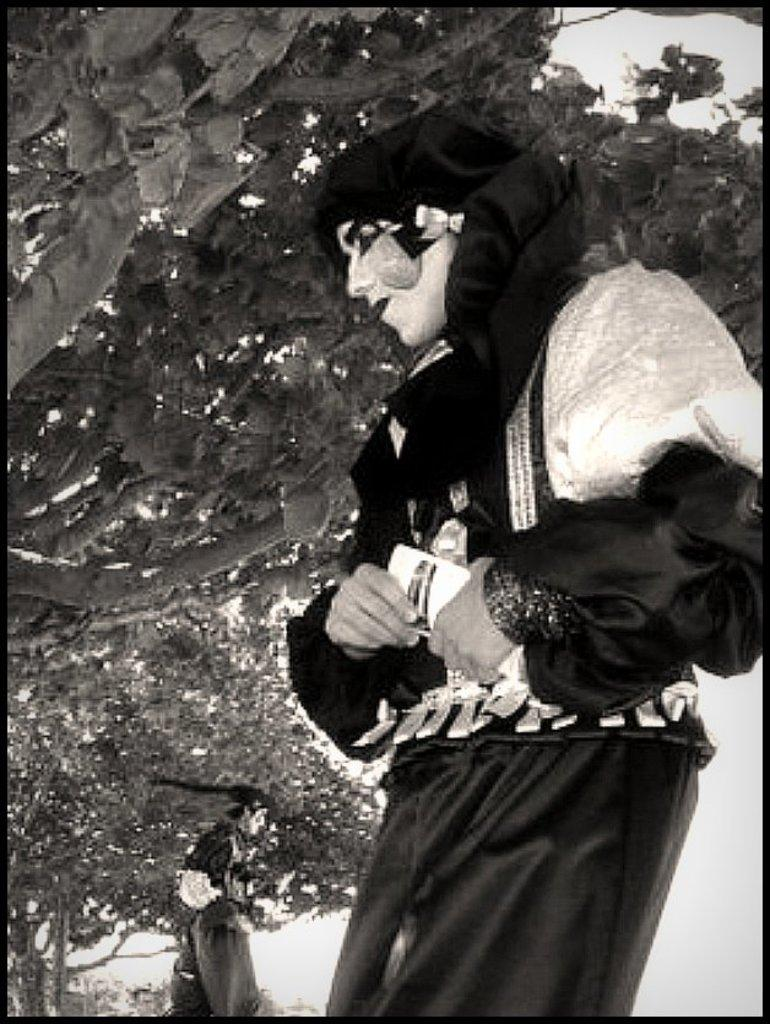What can be seen on the right side of the image? There is a person on the right side of the image. What is the person wearing? The person is wearing a costume. What is the person holding? The person is holding something. What is on the left side of the image? There is another person on the left side of the image and an object. What type of vegetation is present in the image? There are trees in the image. What type of stamp can be seen on the costume of the person on the right side of the image? There is no stamp visible on the costume of the person on the right side of the image. What type of competition is taking place between the two people in the image? There is no competition present in the image; it simply shows two people and an object. 